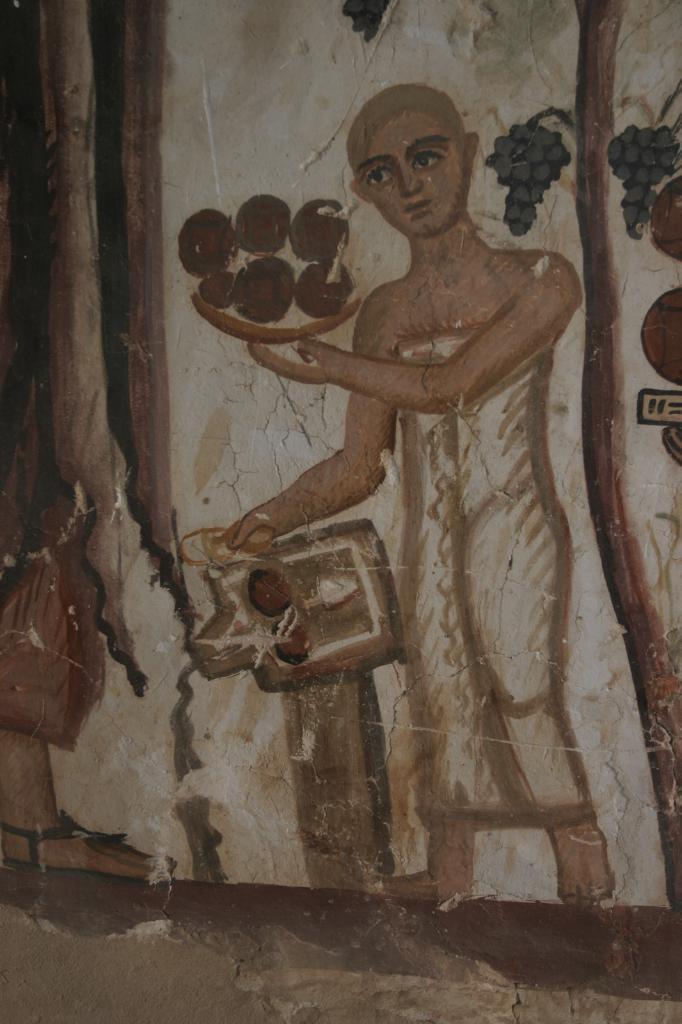Can you describe this image briefly? In this image we can see a wall. On the wall we can see a painting. In the painting we can see a person holding objects. Beside the person we can see fruits and a tree. On the left side, we can see a person. 